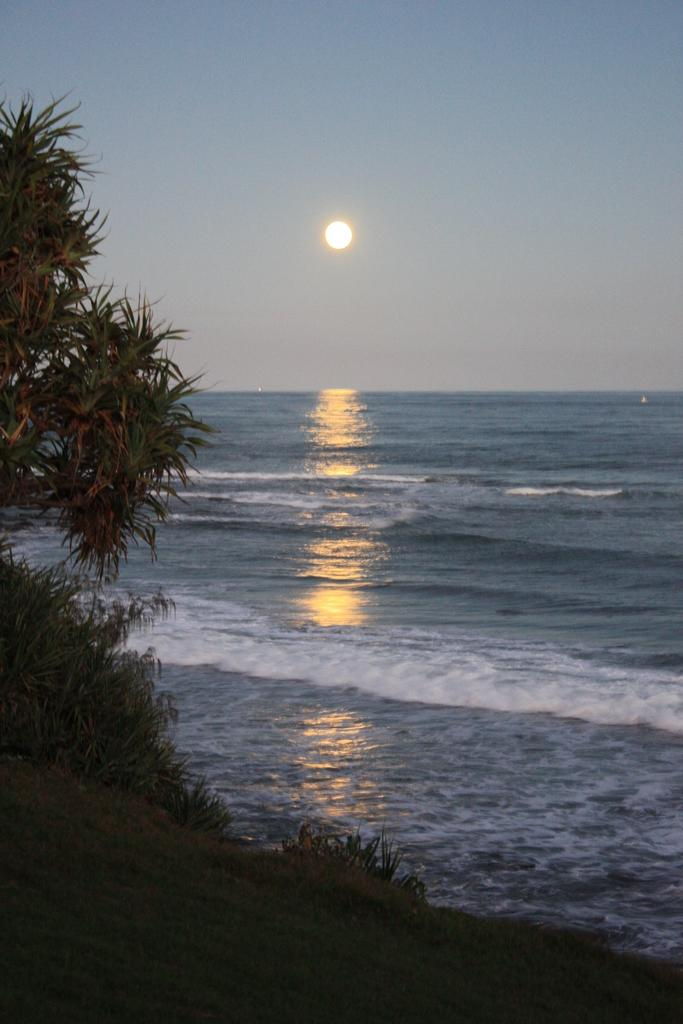What can be seen in the foreground of the image? There are plants and sand in the foreground of the image. What is the main feature in the center of the image? There is a river in the center of the image. What is visible in the background of the image? The sun and the sky are visible in the background of the image. Where are the tomatoes growing in the image? There are no tomatoes present in the image. Is there a swing visible in the image? There is no swing present in the image. 